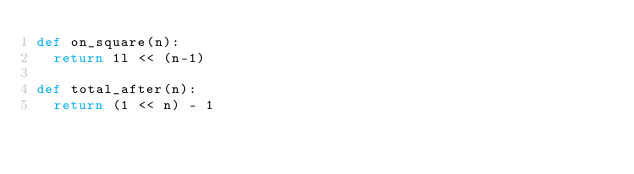Convert code to text. <code><loc_0><loc_0><loc_500><loc_500><_Python_>def on_square(n):
	return 1l << (n-1)

def total_after(n):
	return (1 << n) - 1</code> 